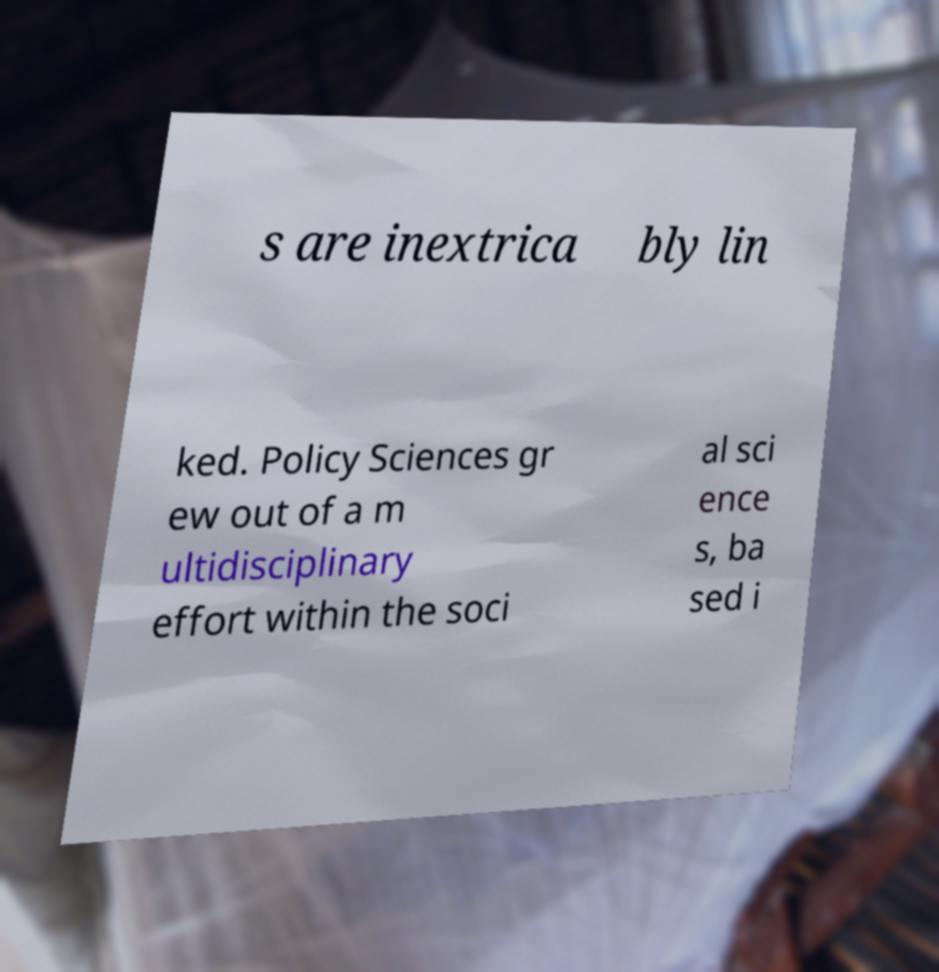What messages or text are displayed in this image? I need them in a readable, typed format. s are inextrica bly lin ked. Policy Sciences gr ew out of a m ultidisciplinary effort within the soci al sci ence s, ba sed i 